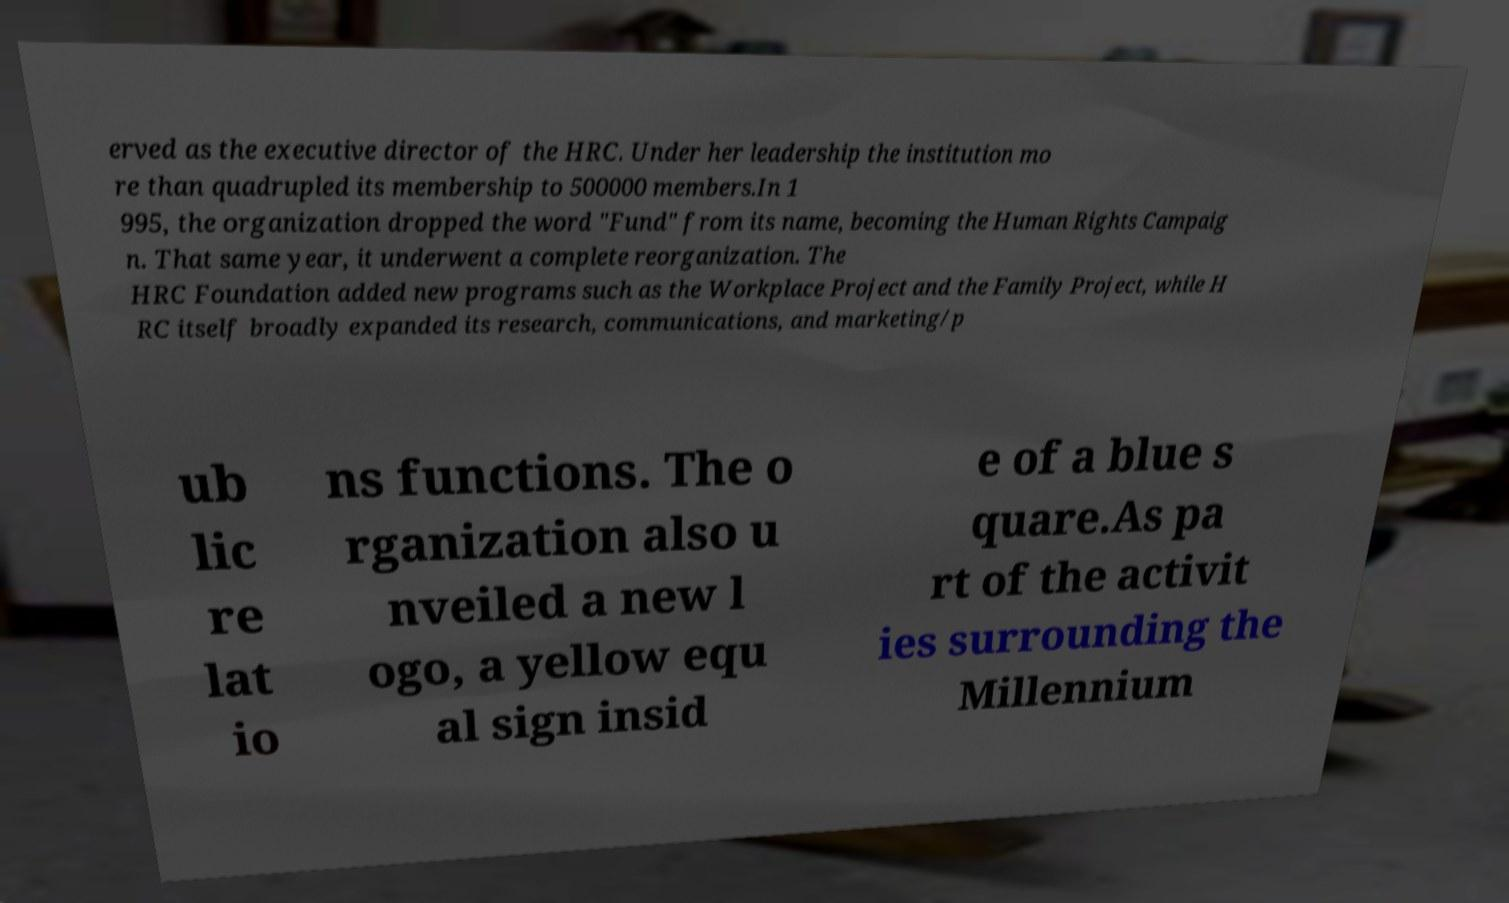I need the written content from this picture converted into text. Can you do that? erved as the executive director of the HRC. Under her leadership the institution mo re than quadrupled its membership to 500000 members.In 1 995, the organization dropped the word "Fund" from its name, becoming the Human Rights Campaig n. That same year, it underwent a complete reorganization. The HRC Foundation added new programs such as the Workplace Project and the Family Project, while H RC itself broadly expanded its research, communications, and marketing/p ub lic re lat io ns functions. The o rganization also u nveiled a new l ogo, a yellow equ al sign insid e of a blue s quare.As pa rt of the activit ies surrounding the Millennium 